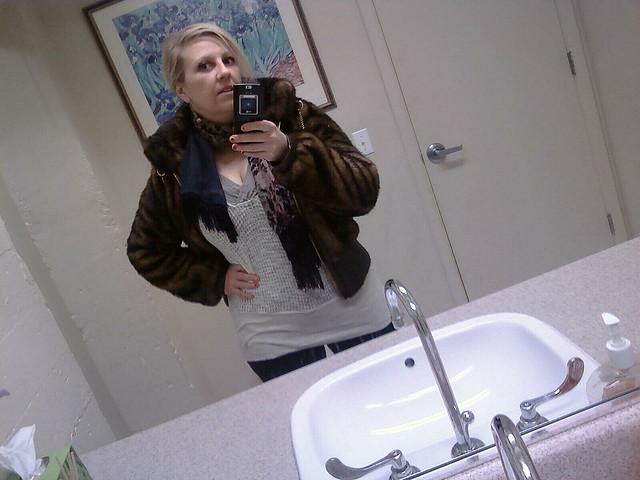What color is the tissue box on the counter?
Give a very brief answer. Green. Is she in a bathroom?
Give a very brief answer. Yes. Where is the woman holding herself?
Quick response, please. Hip. 